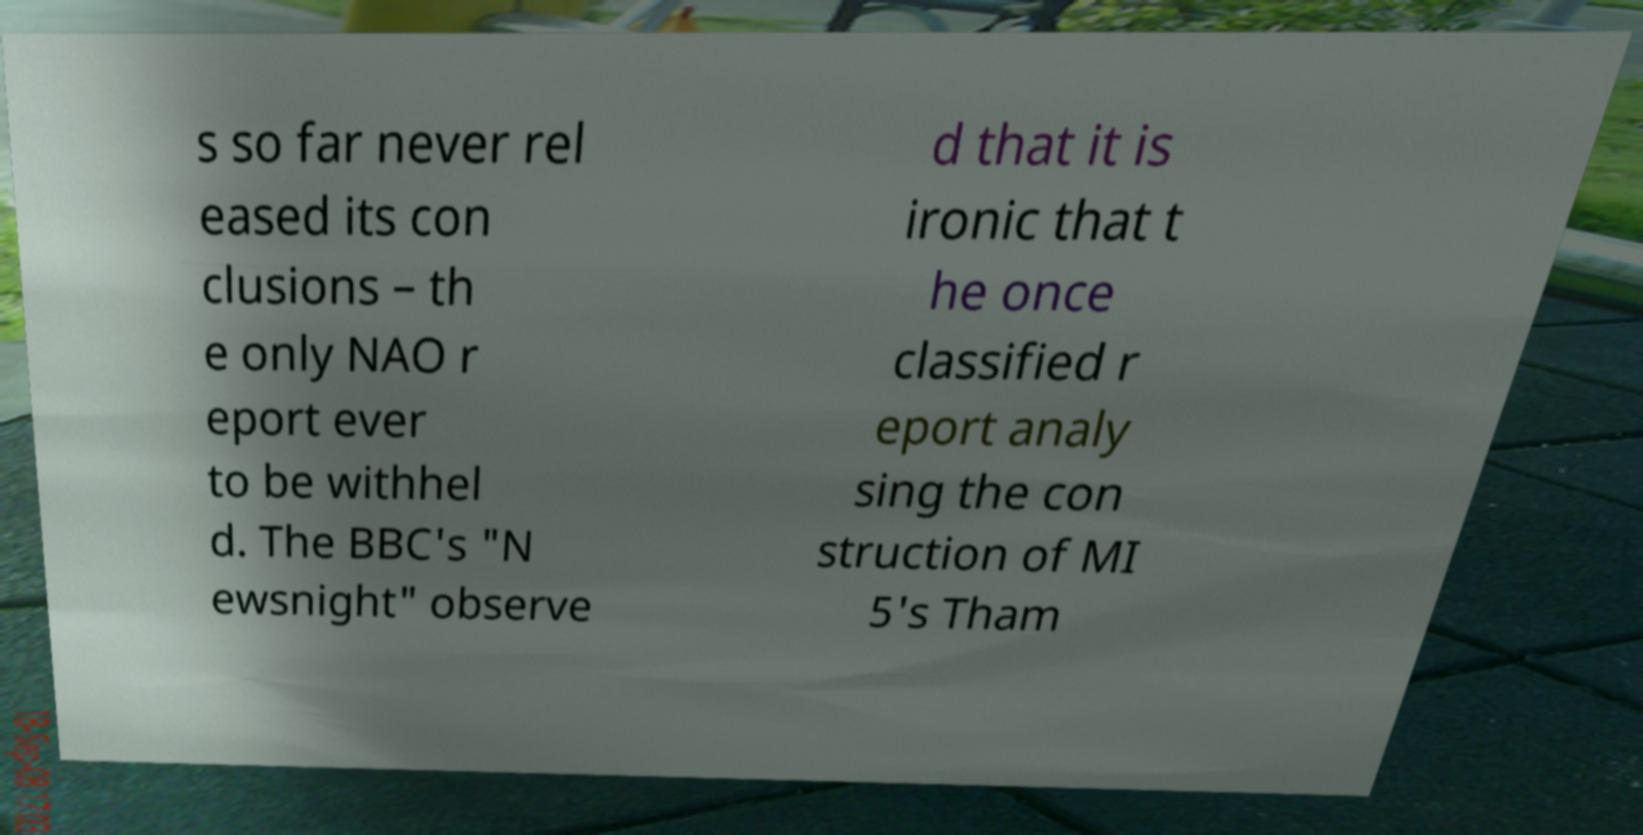There's text embedded in this image that I need extracted. Can you transcribe it verbatim? s so far never rel eased its con clusions – th e only NAO r eport ever to be withhel d. The BBC's "N ewsnight" observe d that it is ironic that t he once classified r eport analy sing the con struction of MI 5's Tham 